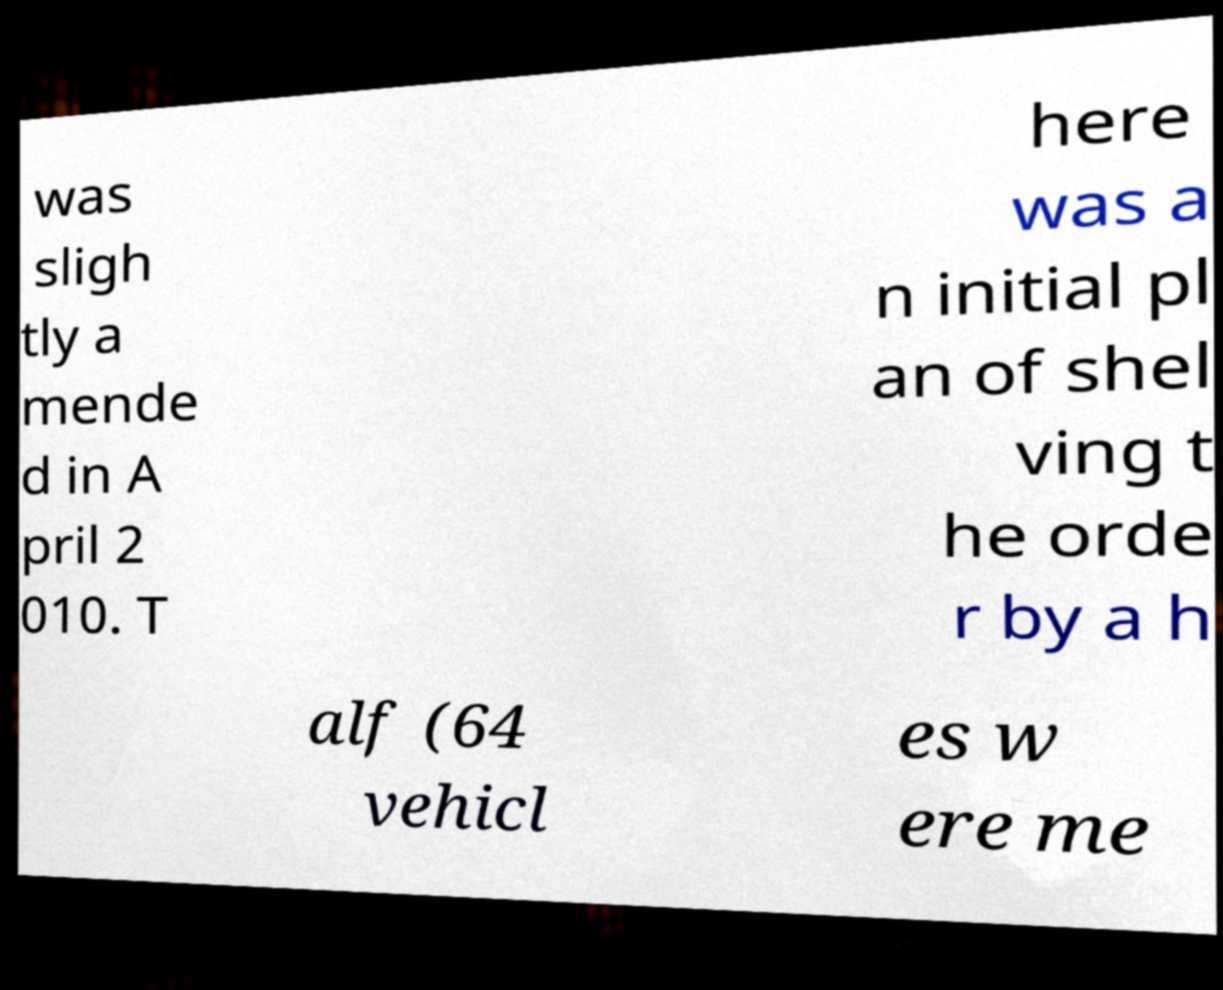There's text embedded in this image that I need extracted. Can you transcribe it verbatim? was sligh tly a mende d in A pril 2 010. T here was a n initial pl an of shel ving t he orde r by a h alf (64 vehicl es w ere me 